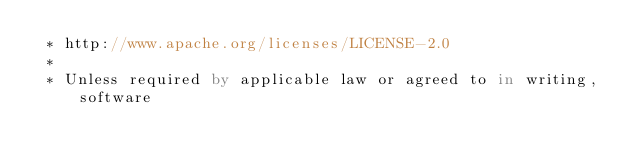Convert code to text. <code><loc_0><loc_0><loc_500><loc_500><_Kotlin_> * http://www.apache.org/licenses/LICENSE-2.0
 *
 * Unless required by applicable law or agreed to in writing, software</code> 